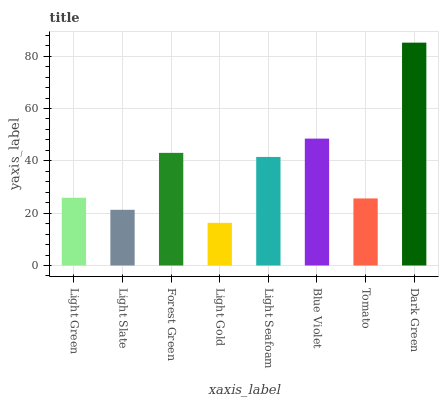Is Light Gold the minimum?
Answer yes or no. Yes. Is Dark Green the maximum?
Answer yes or no. Yes. Is Light Slate the minimum?
Answer yes or no. No. Is Light Slate the maximum?
Answer yes or no. No. Is Light Green greater than Light Slate?
Answer yes or no. Yes. Is Light Slate less than Light Green?
Answer yes or no. Yes. Is Light Slate greater than Light Green?
Answer yes or no. No. Is Light Green less than Light Slate?
Answer yes or no. No. Is Light Seafoam the high median?
Answer yes or no. Yes. Is Light Green the low median?
Answer yes or no. Yes. Is Light Green the high median?
Answer yes or no. No. Is Light Gold the low median?
Answer yes or no. No. 